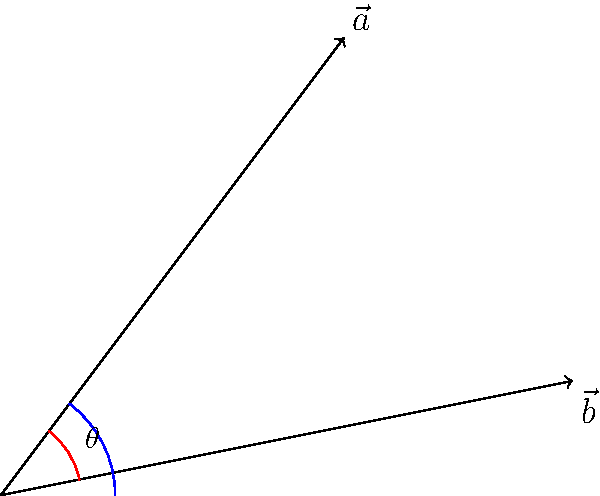In the context of legal positivism, consider two conflicting legal interpretations represented by vectors $\vec{a}$ and $\vec{b}$. If $\vec{a} = (3, 4)$ and $\vec{b} = (5, 1)$, what is the angle $\theta$ between these vectors, representing the degree of divergence in legal interpretation? Express your answer in degrees, rounded to the nearest whole number. To find the angle between two vectors, we can use the dot product formula:

1) The dot product formula: $\cos \theta = \frac{\vec{a} \cdot \vec{b}}{|\vec{a}||\vec{b}|}$

2) Calculate the dot product $\vec{a} \cdot \vec{b}$:
   $\vec{a} \cdot \vec{b} = (3)(5) + (4)(1) = 15 + 4 = 19$

3) Calculate the magnitudes:
   $|\vec{a}| = \sqrt{3^2 + 4^2} = \sqrt{9 + 16} = \sqrt{25} = 5$
   $|\vec{b}| = \sqrt{5^2 + 1^2} = \sqrt{25 + 1} = \sqrt{26}$

4) Substitute into the formula:
   $\cos \theta = \frac{19}{5\sqrt{26}}$

5) Take the inverse cosine (arccos) of both sides:
   $\theta = \arccos(\frac{19}{5\sqrt{26}})$

6) Calculate and convert to degrees:
   $\theta \approx 0.6435 \text{ radians} \approx 36.87°$

7) Round to the nearest whole number:
   $\theta \approx 37°$

This angle represents the degree of divergence between the two legal interpretations in the context of legal positivism.
Answer: 37° 